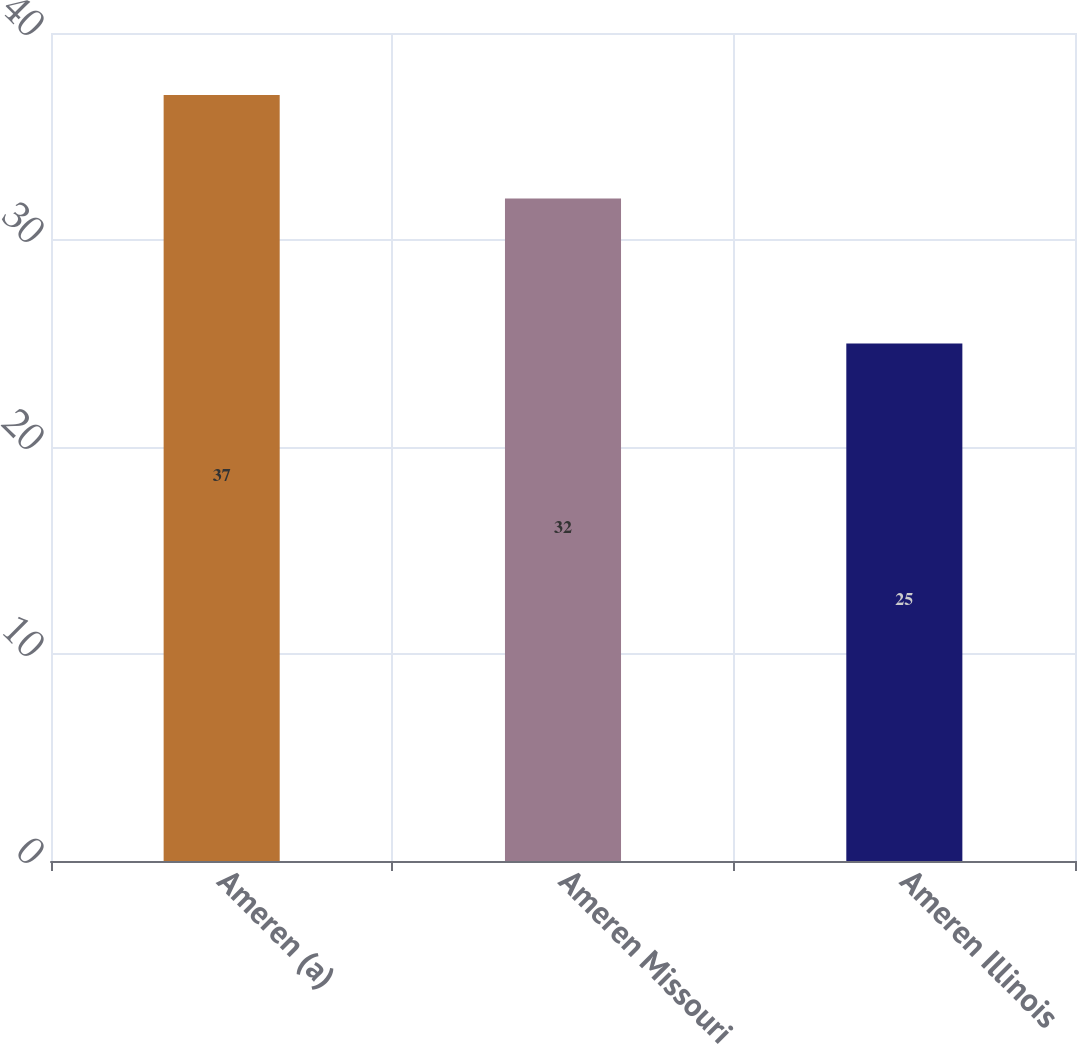Convert chart to OTSL. <chart><loc_0><loc_0><loc_500><loc_500><bar_chart><fcel>Ameren (a)<fcel>Ameren Missouri<fcel>Ameren Illinois<nl><fcel>37<fcel>32<fcel>25<nl></chart> 